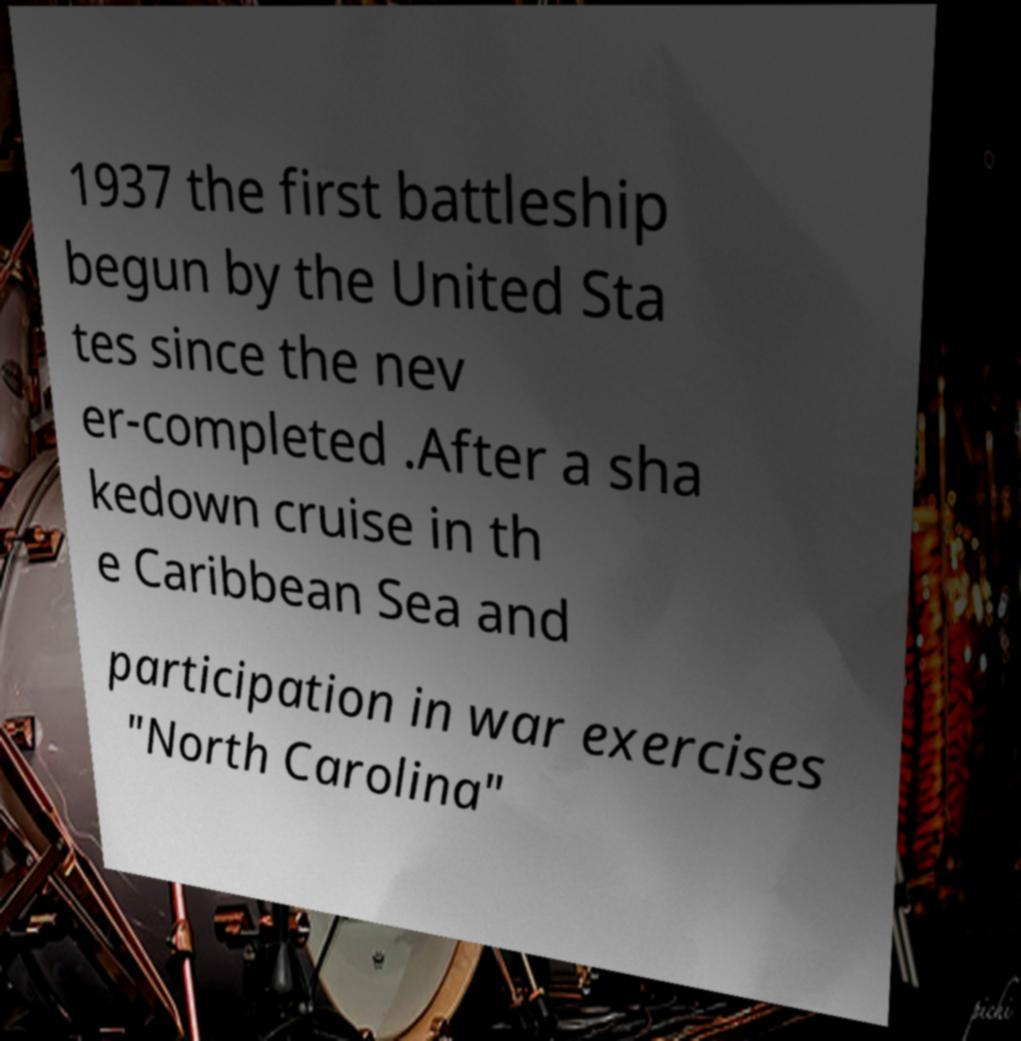For documentation purposes, I need the text within this image transcribed. Could you provide that? 1937 the first battleship begun by the United Sta tes since the nev er-completed .After a sha kedown cruise in th e Caribbean Sea and participation in war exercises "North Carolina" 